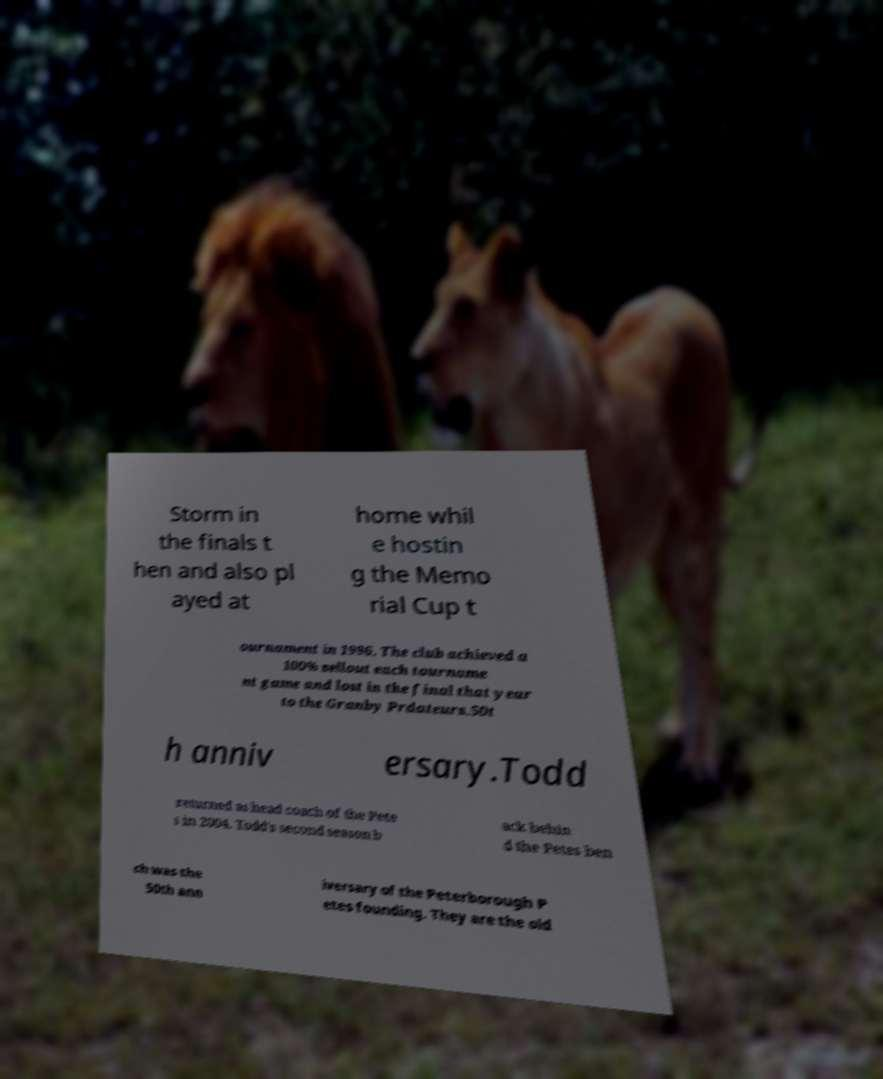Can you read and provide the text displayed in the image?This photo seems to have some interesting text. Can you extract and type it out for me? Storm in the finals t hen and also pl ayed at home whil e hostin g the Memo rial Cup t ournament in 1996. The club achieved a 100% sellout each tourname nt game and lost in the final that year to the Granby Prdateurs.50t h anniv ersary.Todd returned as head coach of the Pete s in 2004. Todd's second season b ack behin d the Petes ben ch was the 50th ann iversary of the Peterborough P etes founding. They are the old 